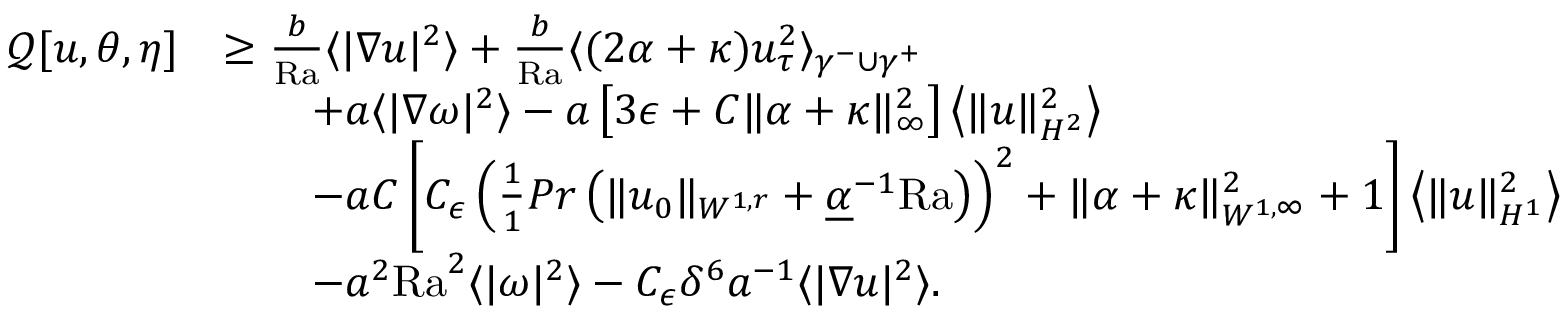Convert formula to latex. <formula><loc_0><loc_0><loc_500><loc_500>\begin{array} { r l } { \mathcal { Q } [ u , \theta , \eta ] } & { \geq \frac { b } { R a } \langle | \nabla u | ^ { 2 } \rangle + \frac { b } { R a } \langle ( 2 \alpha + \kappa ) u _ { \tau } ^ { 2 } \rangle _ { \gamma ^ { - } \cup \gamma ^ { + } } } \\ & { \quad + a \langle | \nabla \omega | ^ { 2 } \rangle - a \left [ 3 \epsilon + C \| \alpha + \kappa \| _ { \infty } ^ { 2 } \right ] \left \langle \| u \| _ { H ^ { 2 } } ^ { 2 } \right \rangle } \\ & { \quad - a C \left [ C _ { \epsilon } \left ( \frac { 1 } { 1 } { P r } \left ( \| u _ { 0 } \| _ { W ^ { 1 , r } } + \underline { \alpha } ^ { - 1 } { R a } \right ) \right ) ^ { 2 } + \| \alpha + \kappa \| _ { W ^ { 1 , \infty } } ^ { 2 } + 1 \right ] \left \langle \| u \| _ { H ^ { 1 } } ^ { 2 } \right \rangle } \\ & { \quad - a ^ { 2 } { R a } ^ { 2 } \langle | \omega | ^ { 2 } \rangle - C _ { \epsilon } \delta ^ { 6 } a ^ { - 1 } \langle | \nabla u | ^ { 2 } \rangle . } \end{array}</formula> 